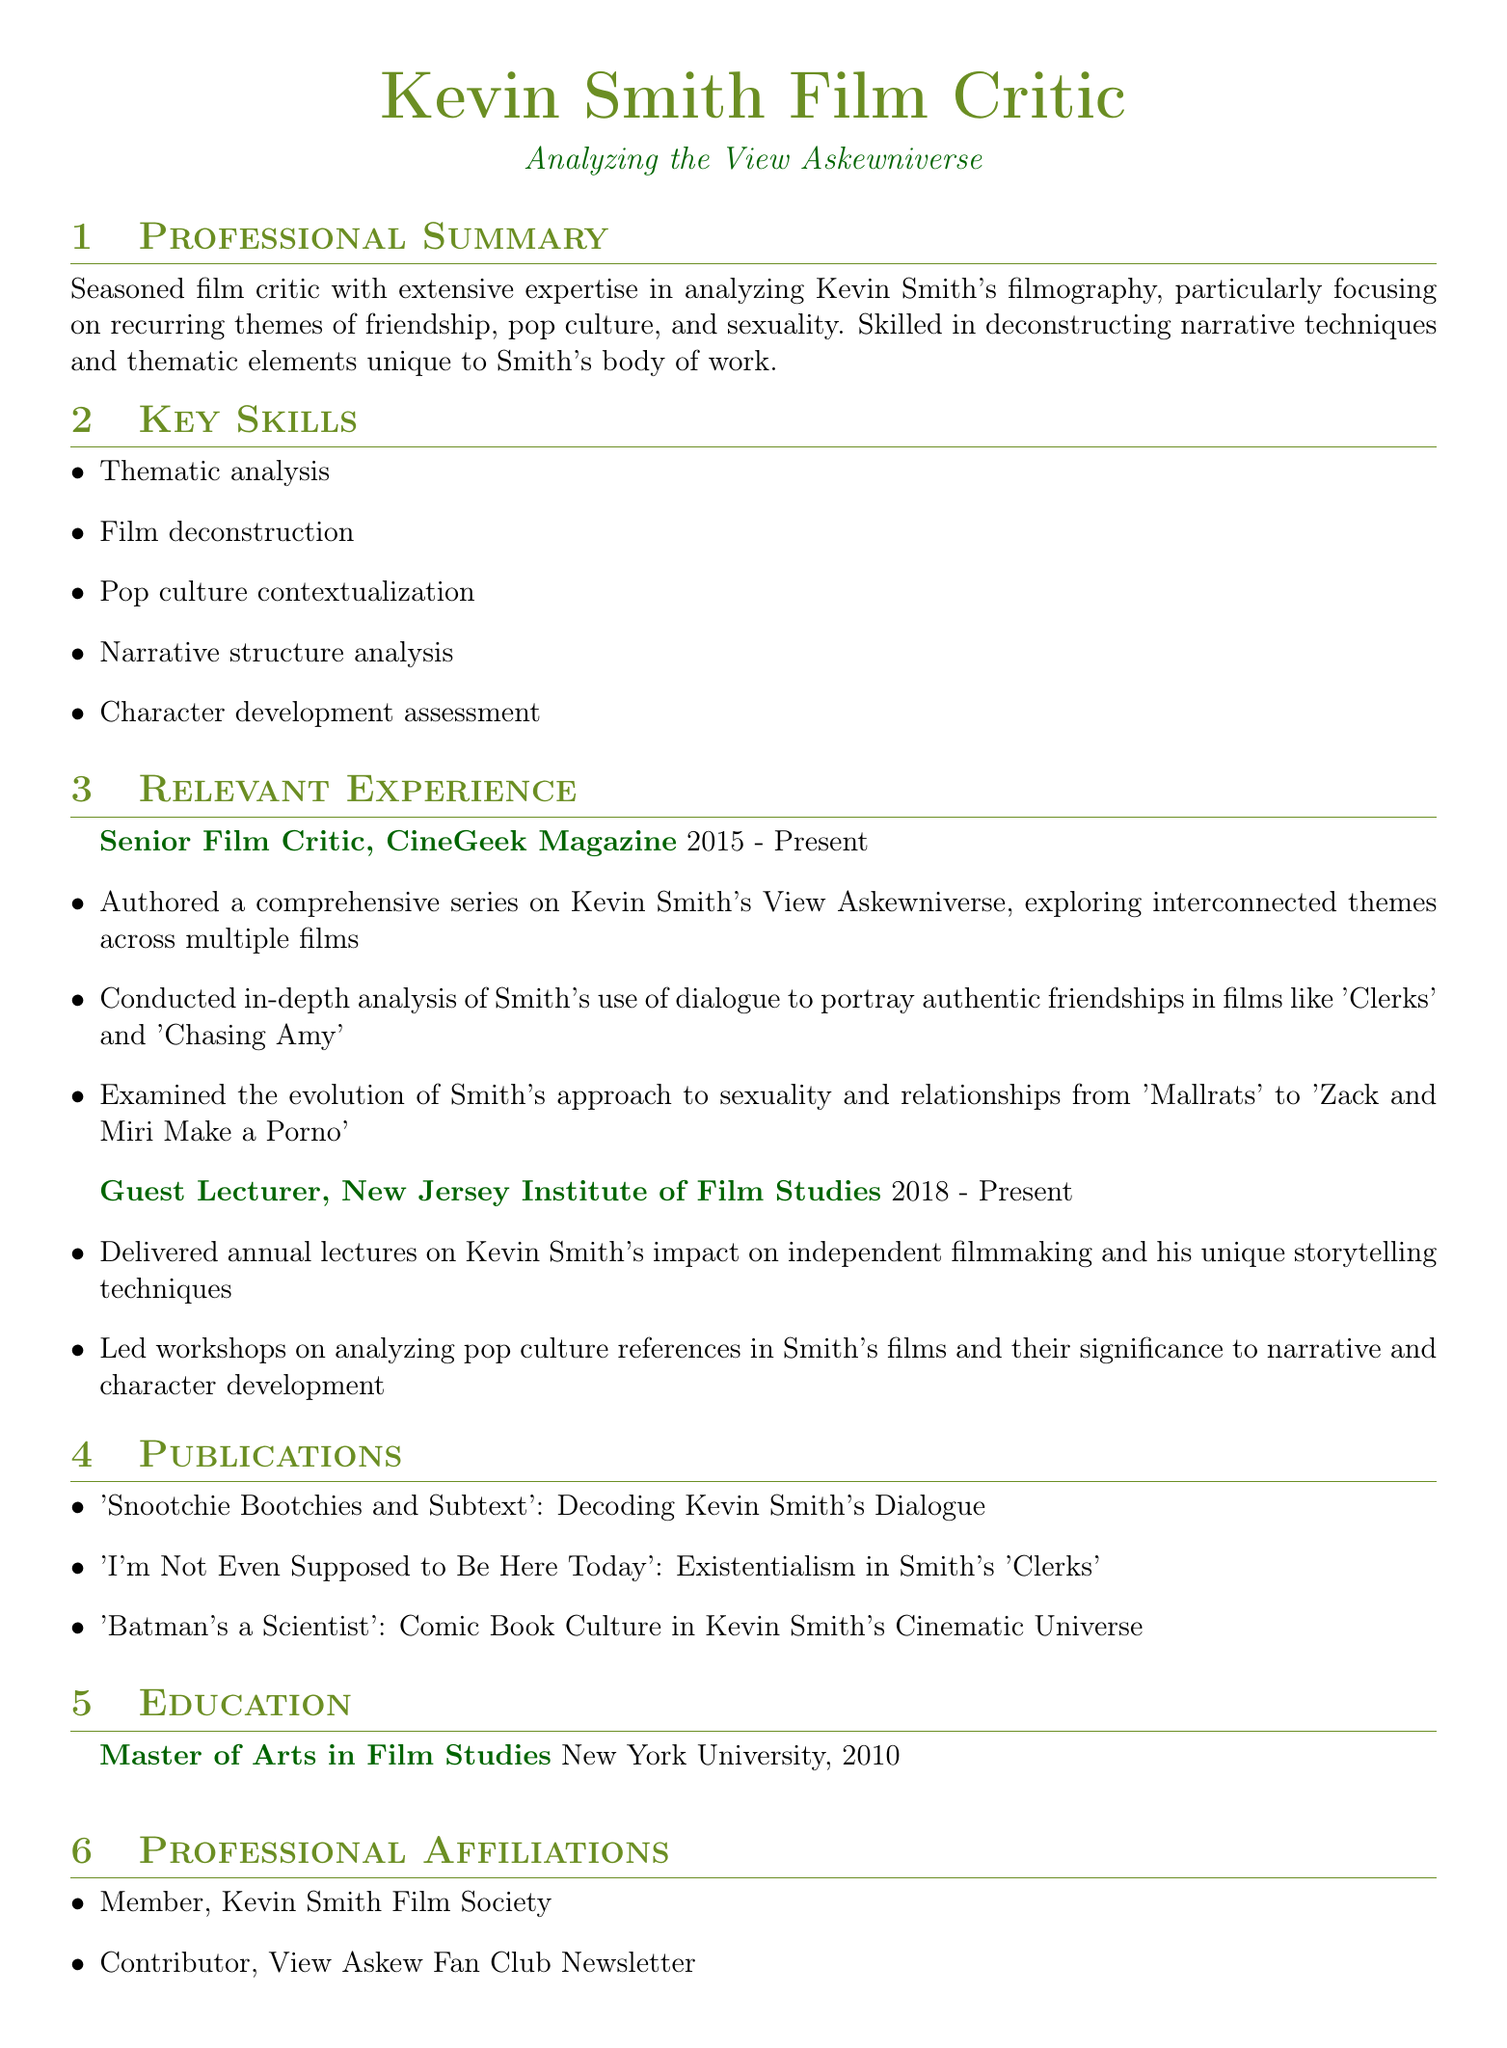What is the job title held at CineGeek Magazine? The job title is listed in the relevant experience section of the document.
Answer: Senior Film Critic What year did the individual graduate from New York University? The graduation year is found in the education section of the document.
Answer: 2010 Which film's relationships are analyzed from 'Mallrats' to 'Zack and Miri Make a Porno'? This information pertains to the specific analysis mentioned in the responsibilities.
Answer: sexuality How long has the individual been a guest lecturer at the New Jersey Institute of Film Studies? The duration of experience is given in the relevant experience section.
Answer: 5 years Name one publication authored by the individual. The titles of the publications are listed in the publications section.
Answer: 'Snootchie Bootchies and Subtext' What recurring themes are analyzed in Kevin Smith's filmography? The themes are mentioned in the professional summary at the beginning of the document.
Answer: friendship, pop culture, sexuality How many key skills are listed in the document? The skills are detailed in the key skills section, and the count can be determined directly.
Answer: 5 What type of analysis does the individual conduct on Smith's dialogue? This specific type of analysis is described in the responsibilities under the Senior Film Critic role.
Answer: thematic analysis What organization is the individual a member of? This information can be found in the professional affiliations section of the document.
Answer: Kevin Smith Film Society 